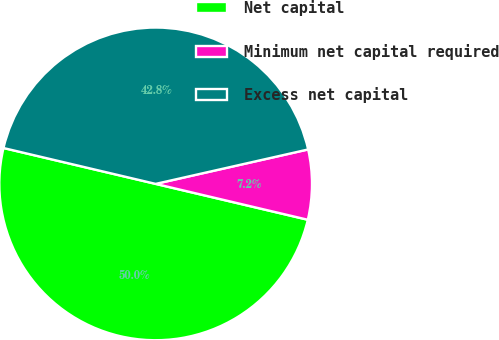Convert chart to OTSL. <chart><loc_0><loc_0><loc_500><loc_500><pie_chart><fcel>Net capital<fcel>Minimum net capital required<fcel>Excess net capital<nl><fcel>50.0%<fcel>7.22%<fcel>42.78%<nl></chart> 